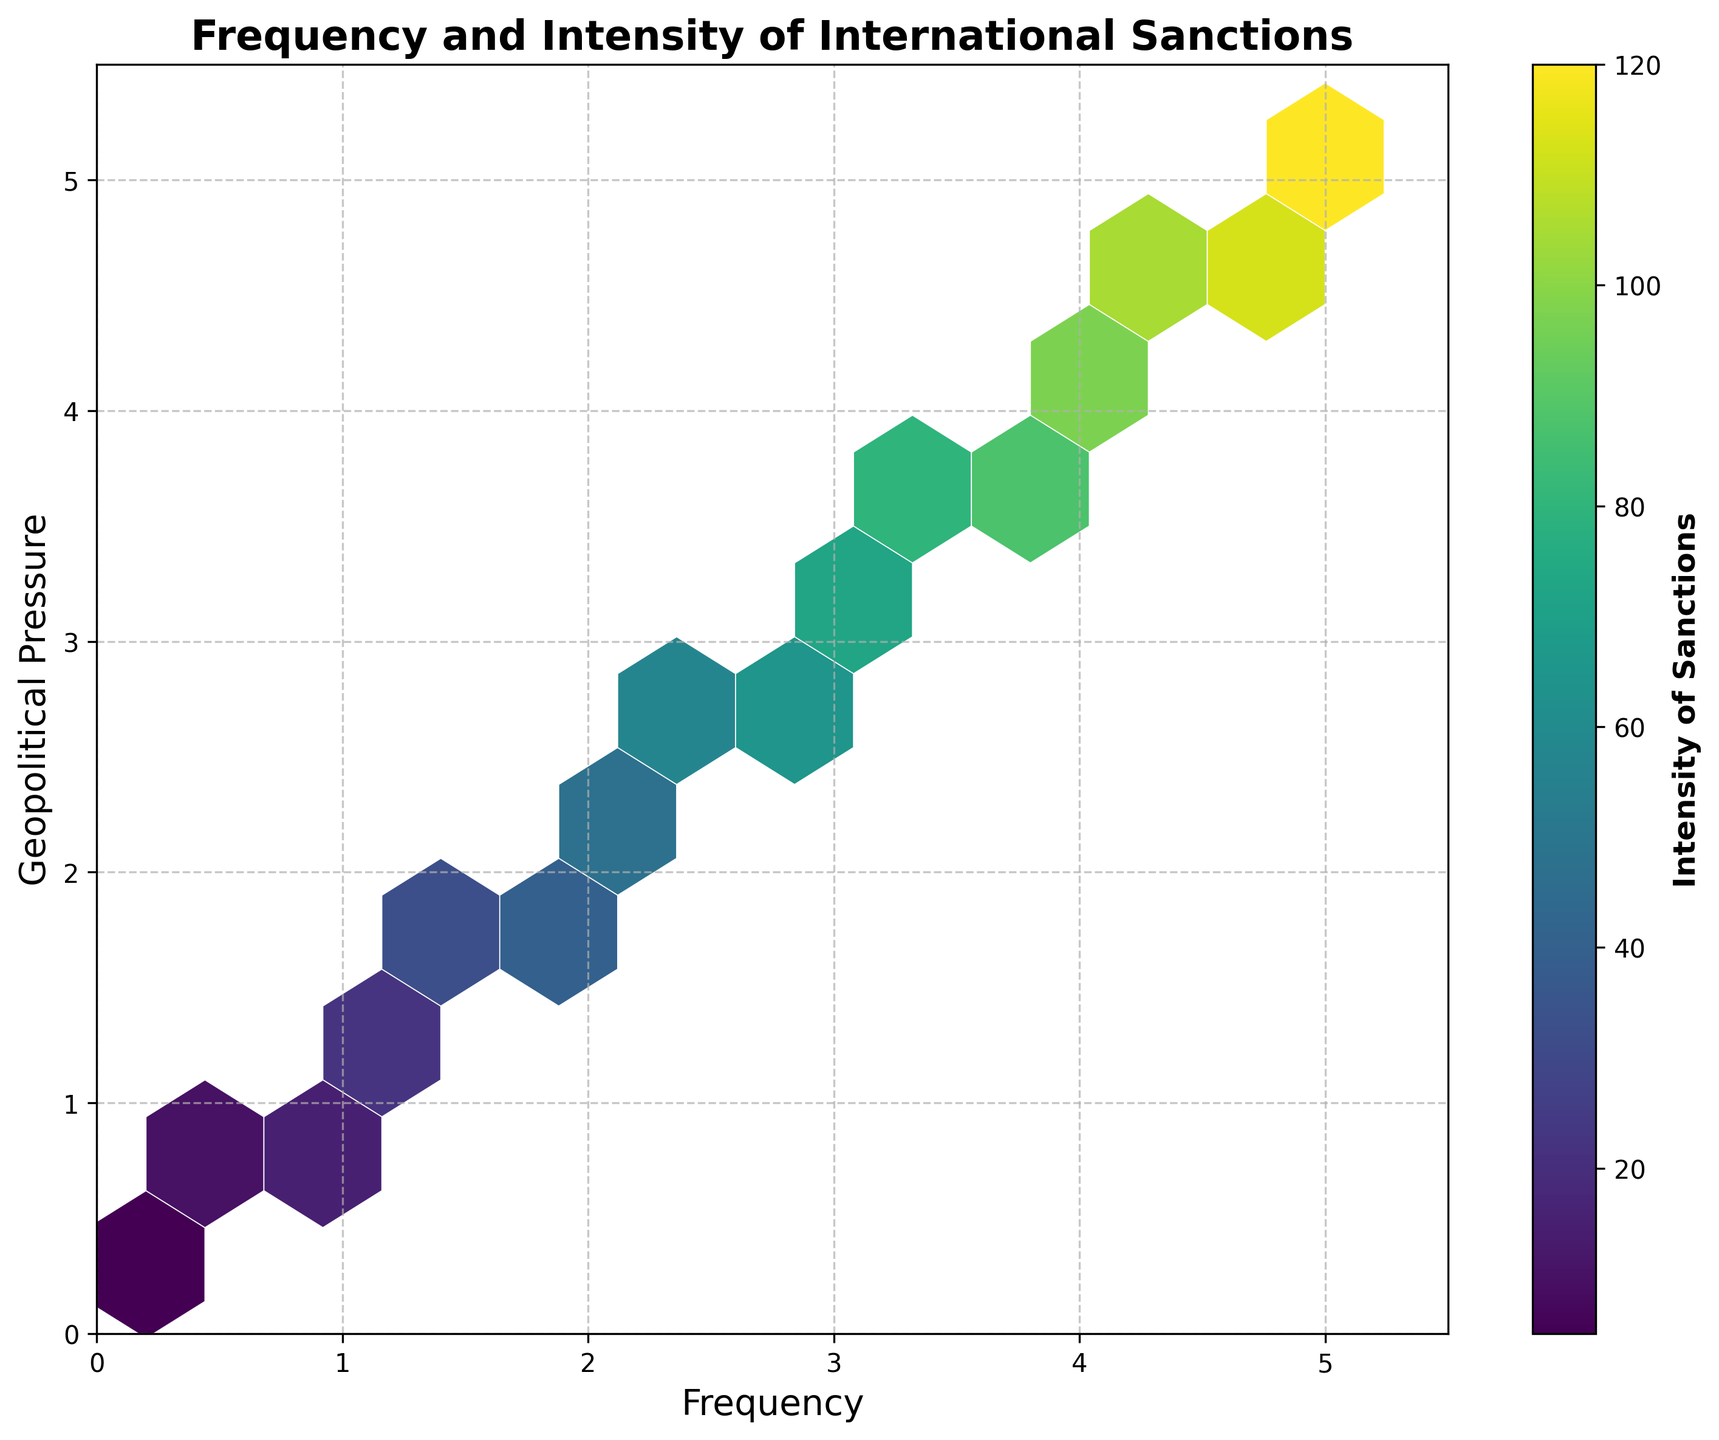What is the title of the figure? The title of the figure is located at the top center and provides a summary of the plot's data. Simply look at the text at the top.
Answer: Frequency and Intensity of International Sanctions What do the x and y axes represent in this plot? The labels of the axes indicate what each axis represents. The x-axis label is at the bottom, and the y-axis label is on the left side.
Answer: Frequency and Geopolitical Pressure How many data points are represented in the hexbin plot? Each hexagon in the plot represents a bin of data points. Count the bins in the figure or check for the total number indicated by the plot.
Answer: 25 Which color indicates the highest intensity of sanctions? Look at the colorbar on the right of the plot which depicts the scale of intensity. The color at the top of the scale represents the highest intensity.
Answer: Dark purple What is the range of the x-axis? Look at the x-axis to observe the scale at the bottom, starting from the leftmost point to the rightmost point.
Answer: 0 to 5.5 What is the range of the y-axis? Look at the y-axis to observe the scale on the left side, starting from the bottom to the topmost point.
Answer: 0 to 5.5 Where is the highest density of data points located in terms of frequency and geopolitical pressure? The highest density of data points is shown by the darkest hexagon on the plot. Trace the position along the x and y axes, respectively.
Answer: Around (4.5, 4.5) How does the intensity trend with increasing frequency and geopolitical pressure? Observe the gradient of colors in the plot. As both the frequency and geopolitical pressure increase, the color of the hexagons changes. Identify the trend in these changes.
Answer: It increases Is there a region with low frequency and high intensity of sanctions? Look for a lighter colored hexagon on the left side of the plot (lower frequency) but a higher value on the color scale (high intensity).
Answer: No 